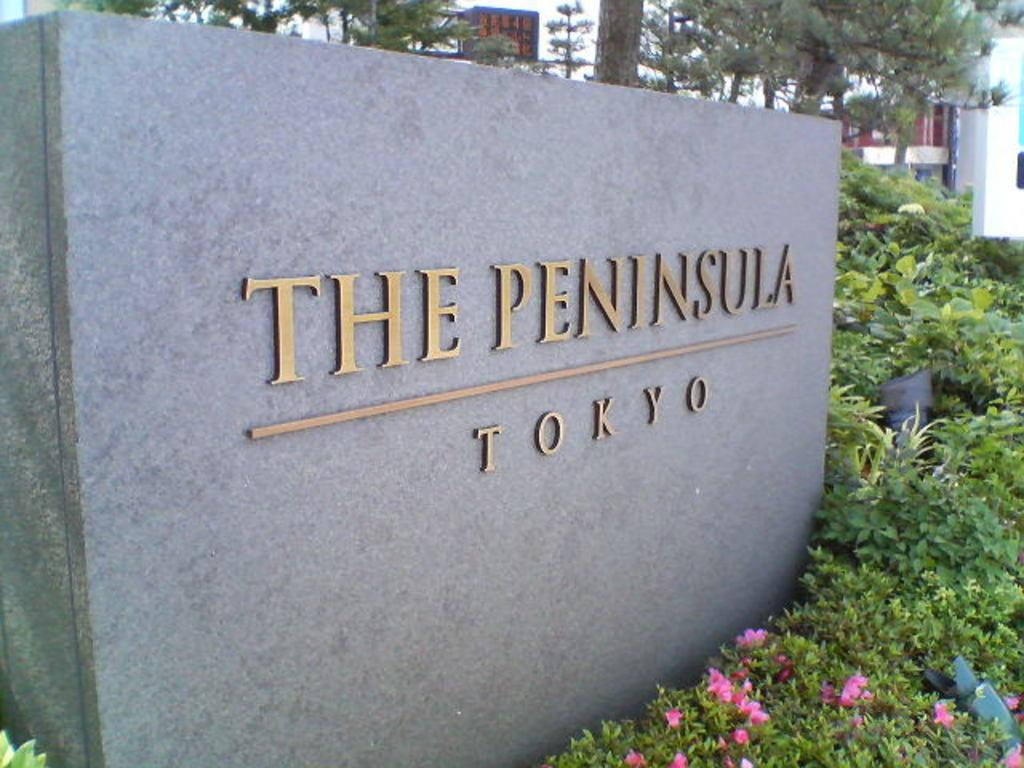What is the main feature in the center of the image? There is a wall with text in the center of the image. What can be seen in front of the wall? There are plants with flowers and objects in front of the wall. What is visible in the background of the image? There are buildings and trees in the background of the image. What type of harmony can be heard in the image? There is no audible sound or music in the image, so it is not possible to determine if any harmony can be heard. 